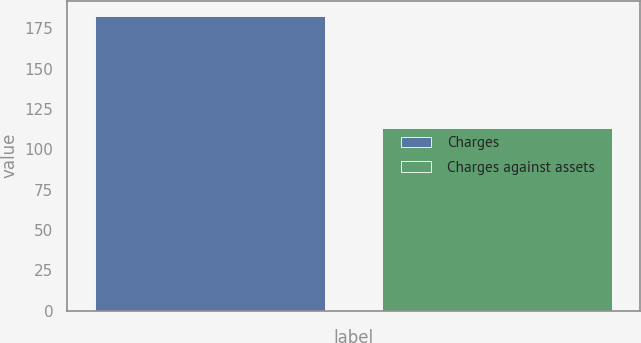Convert chart. <chart><loc_0><loc_0><loc_500><loc_500><bar_chart><fcel>Charges<fcel>Charges against assets<nl><fcel>182.8<fcel>113.3<nl></chart> 